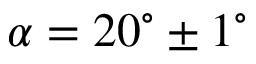<formula> <loc_0><loc_0><loc_500><loc_500>\alpha = 2 0 ^ { \circ } \pm 1 ^ { \circ }</formula> 